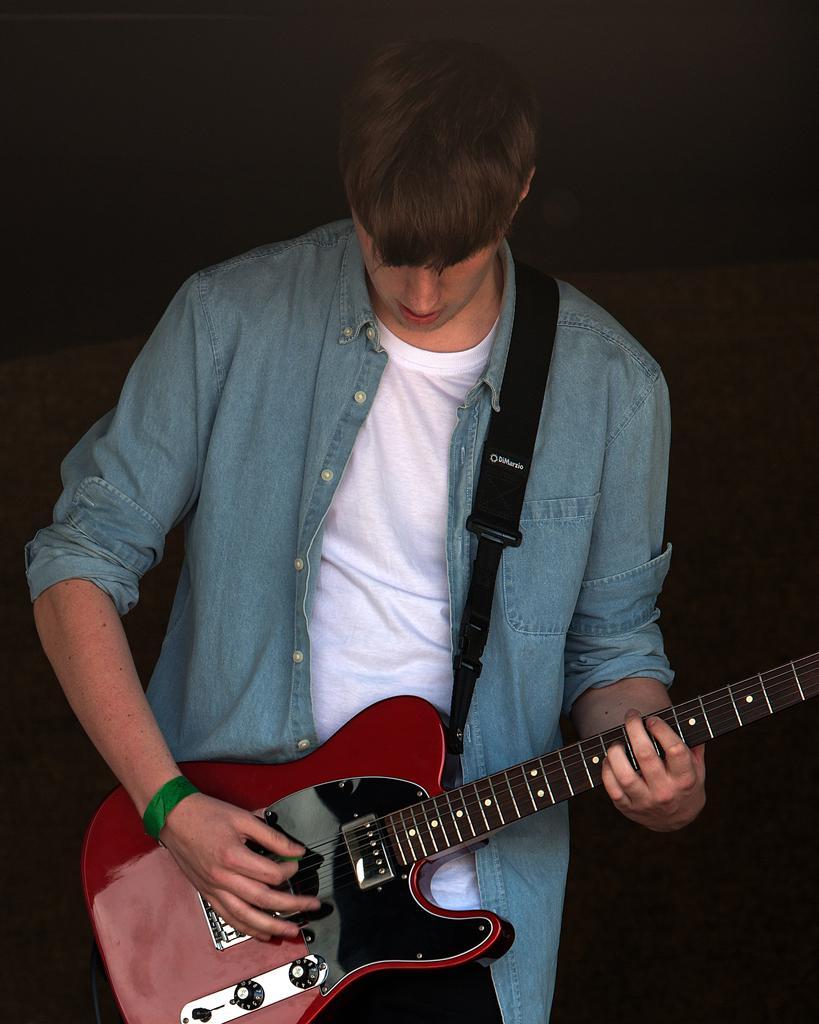Please provide a concise description of this image. This man wore jacket is playing a guitar. 